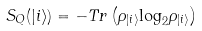Convert formula to latex. <formula><loc_0><loc_0><loc_500><loc_500>S _ { Q } ( | i \rangle ) = - T r \left ( { \rho } _ { | i \rangle } { \log } _ { 2 } { \rho } _ { | i \rangle } \right )</formula> 